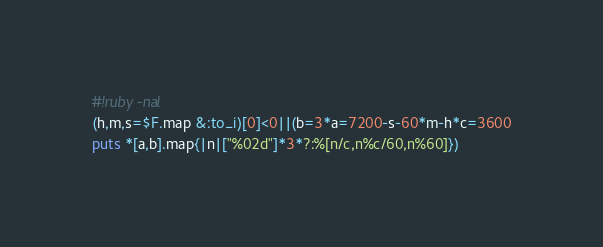Convert code to text. <code><loc_0><loc_0><loc_500><loc_500><_Ruby_>#!ruby -nal
(h,m,s=$F.map &:to_i)[0]<0||(b=3*a=7200-s-60*m-h*c=3600
puts *[a,b].map{|n|["%02d"]*3*?:%[n/c,n%c/60,n%60]})</code> 